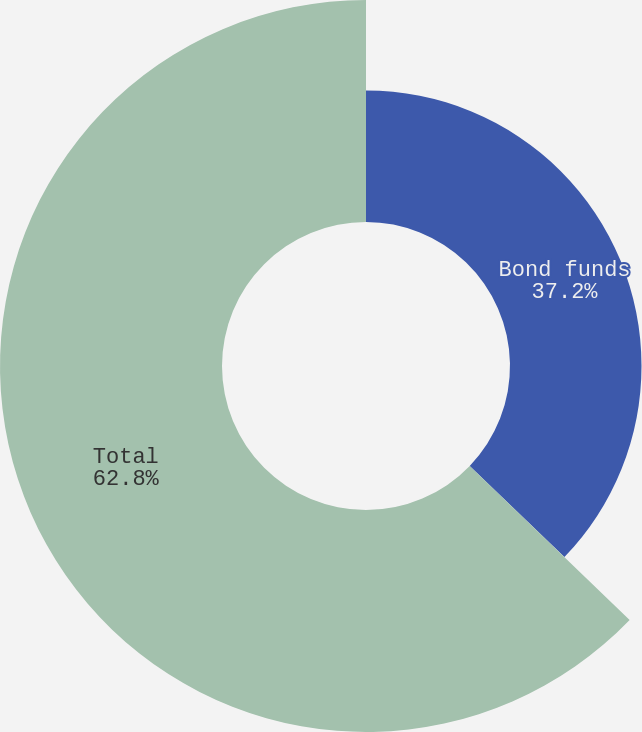Convert chart to OTSL. <chart><loc_0><loc_0><loc_500><loc_500><pie_chart><fcel>Bond funds<fcel>Total<nl><fcel>37.2%<fcel>62.8%<nl></chart> 